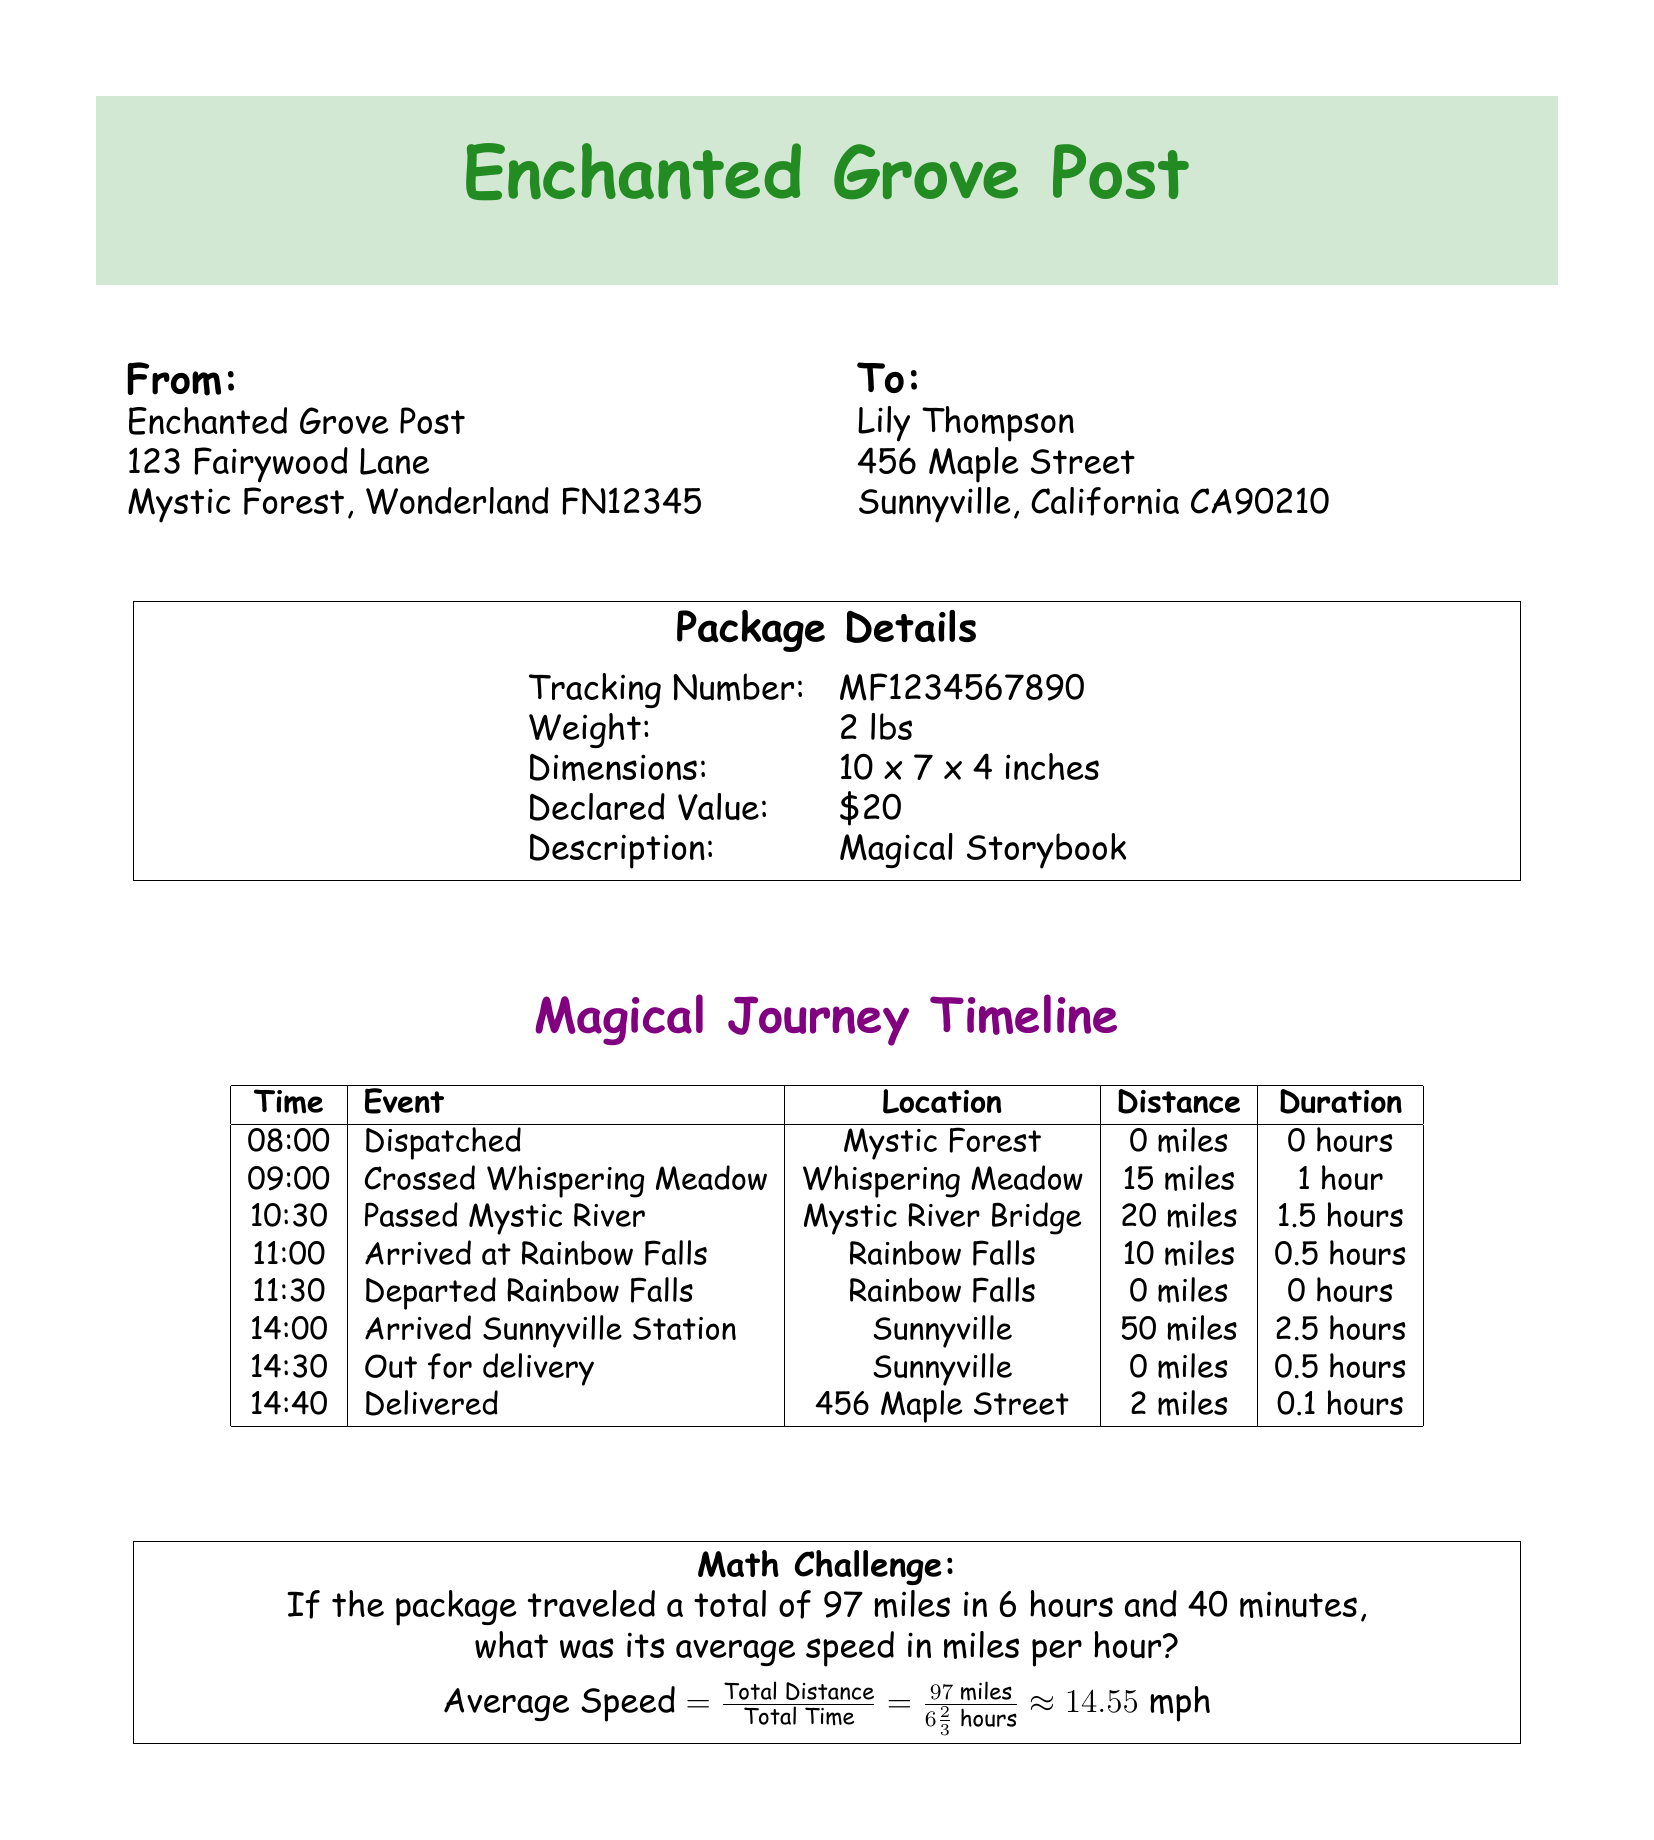What is the tracking number? The tracking number is listed in the package details section of the document.
Answer: MF1234567890 What is the declared value of the package? The declared value of the package is specified in the package details.
Answer: $20 What is the weight of the package? The weight is mentioned in the package details section.
Answer: 2 lbs What time did the package arrive at Rainbow Falls? The arrival time at Rainbow Falls is noted in the timeline of events.
Answer: 11:00 How far did the package travel to reach Sunnyville Station? The distance traveled to Sunnyville Station can be found in the timeline.
Answer: 50 miles What is the average speed of the package? The average speed is calculated based on the total distance and total time provided in the math challenge.
Answer: 14.55 mph How many miles did the package travel in the first hour? The distance traveled in the first hour can be found in the timeline.
Answer: 15 miles What was the total duration of the package's journey? The total duration is the sum of times listed in the timeline, which indicates the journey from dispatch to delivery.
Answer: 6 hours and 40 minutes What is the final destination address? The final destination is specified in the "To" section of the document.
Answer: 456 Maple Street, Sunnyville, California CA90210 